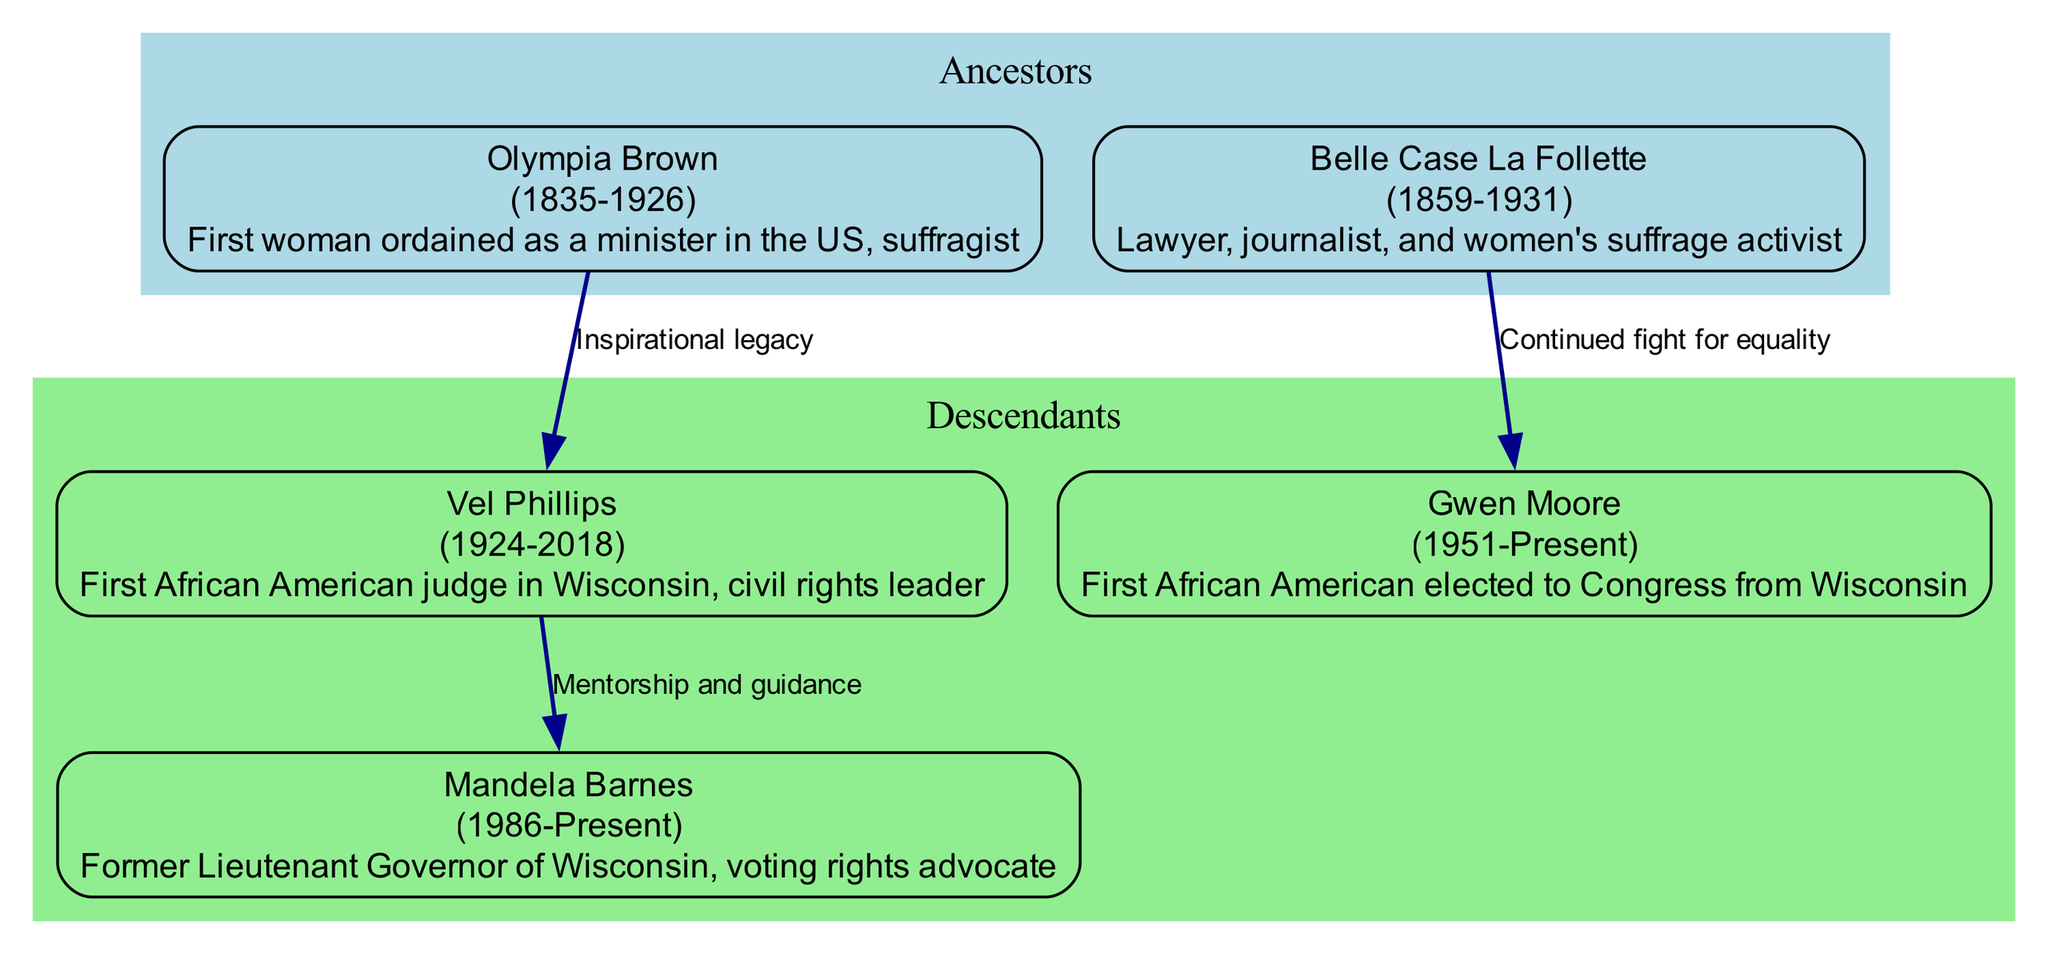What is the birth year of Olympia Brown? The diagram directly states the birth year for Olympia Brown under her name. It lists "1835" next to her name.
Answer: 1835 Who is the first African American elected to Congress from Wisconsin? The descendant section of the diagram shows Gwen Moore with the description stating she is the first African American elected to Congress from Wisconsin.
Answer: Gwen Moore How many generations are represented in the diagram? By examining the relationships from the ancestors to the descendants, there are two generations: Olympia Brown and Belle Case La Follette as the ancestors and Vel Phillips, Gwen Moore, and Mandela Barnes as descendants.
Answer: 2 What type of relationship does Vel Phillips have with Mandela Barnes? The connection from Vel Phillips to Mandela Barnes is labeled "Mentorship and guidance," indicating the nature of their relationship in the diagram.
Answer: Mentorship and guidance Which ancestor's descendants include the first African American judge in Wisconsin? The diagram shows that Vel Phillips is a descendant of Olympia Brown, and he is noted as the first African American judge in Wisconsin. Thus, the ancestor who has a descendant with this distinction is Olympia Brown.
Answer: Olympia Brown What is the death year of Belle Case La Follette? The diagram directly notes Belle Case La Follette's death year beside her name, listed as "1931."
Answer: 1931 How is Gwen Moore connected to Belle Case La Follette? The connection from Belle Case La Follette to Gwen Moore is labeled "Continued fight for equality," indicating their relationship is based on shared activism for voting rights.
Answer: Continued fight for equality Which descendant was born in 1986? The diagram provides the birth year next to Mandela Barnes's name as "1986." Therefore, he is the descendant born in that year.
Answer: Mandela Barnes What color represents the ancestors in the diagram? The diagram shows that the ancestors are in a cluster filled with light blue, indicating the chosen color for that section.
Answer: Light blue 